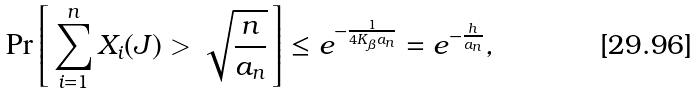<formula> <loc_0><loc_0><loc_500><loc_500>\Pr \left [ \, \sum _ { i = 1 } ^ { n } X _ { i } ( J ) > \sqrt { \frac { n } { a _ { n } } } \, \right ] & \leq e ^ { - \frac { 1 } { 4 K _ { \beta } a _ { n } } } = e ^ { - \frac { h } { a _ { n } } } ,</formula> 